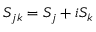<formula> <loc_0><loc_0><loc_500><loc_500>S _ { j k } = S _ { j } + i S _ { k }</formula> 